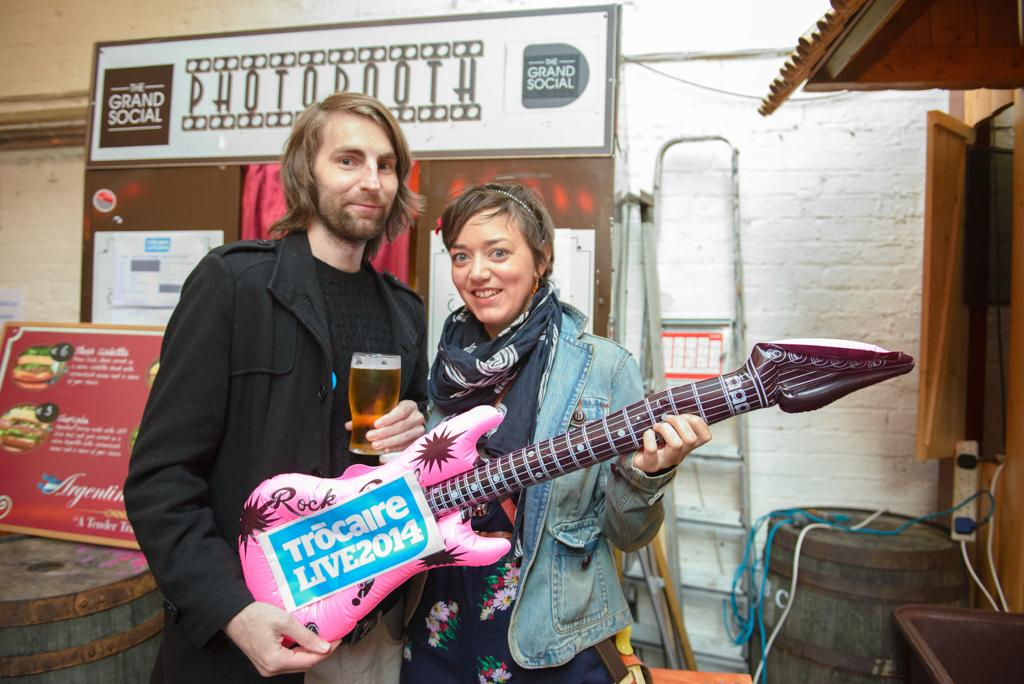How many people are present in the image? There are two people, a man and a woman, present in the image. What are the man and woman holding in the image? The man and woman are holding a balloon in the image. What object is the man holding in addition to the balloon? The man is holding a guitar in the image. Can you describe the background of the image? There are banners, a wall, a ladder, a drum, wires, and a door visible in the background of the image. What type of lumber is being used to construct the flight in the image? There is no flight or lumber present in the image. How many elbows can be seen on the man in the image? It is impossible to determine the number of elbows on the man in the image, as elbows are not visible in the image. 